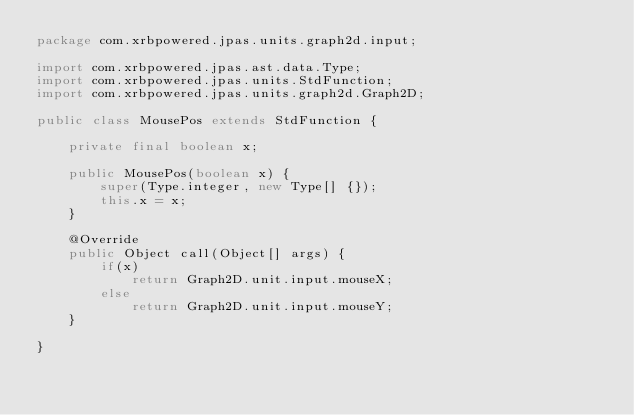Convert code to text. <code><loc_0><loc_0><loc_500><loc_500><_Java_>package com.xrbpowered.jpas.units.graph2d.input;

import com.xrbpowered.jpas.ast.data.Type;
import com.xrbpowered.jpas.units.StdFunction;
import com.xrbpowered.jpas.units.graph2d.Graph2D;

public class MousePos extends StdFunction {

	private final boolean x;
	
	public MousePos(boolean x) {
		super(Type.integer, new Type[] {});
		this.x = x;
	}
	
	@Override
	public Object call(Object[] args) {
		if(x)
			return Graph2D.unit.input.mouseX;
		else
			return Graph2D.unit.input.mouseY;
	}

}
</code> 